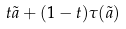<formula> <loc_0><loc_0><loc_500><loc_500>t \tilde { a } + ( 1 - t ) \tau ( \tilde { a } )</formula> 